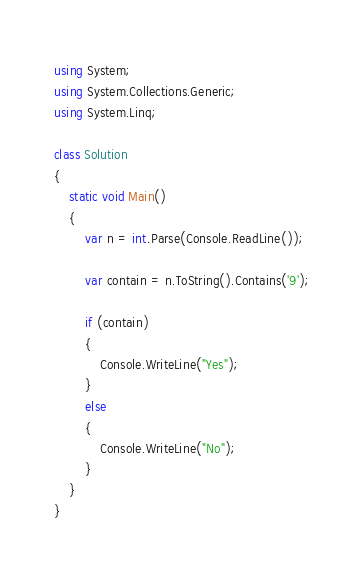<code> <loc_0><loc_0><loc_500><loc_500><_C#_>using System;
using System.Collections.Generic;
using System.Linq;

class Solution
{
    static void Main()
    {
        var n = int.Parse(Console.ReadLine());

        var contain = n.ToString().Contains('9');

        if (contain)
        {
            Console.WriteLine("Yes");
        }
        else
        {
            Console.WriteLine("No");
        }
    }
}</code> 